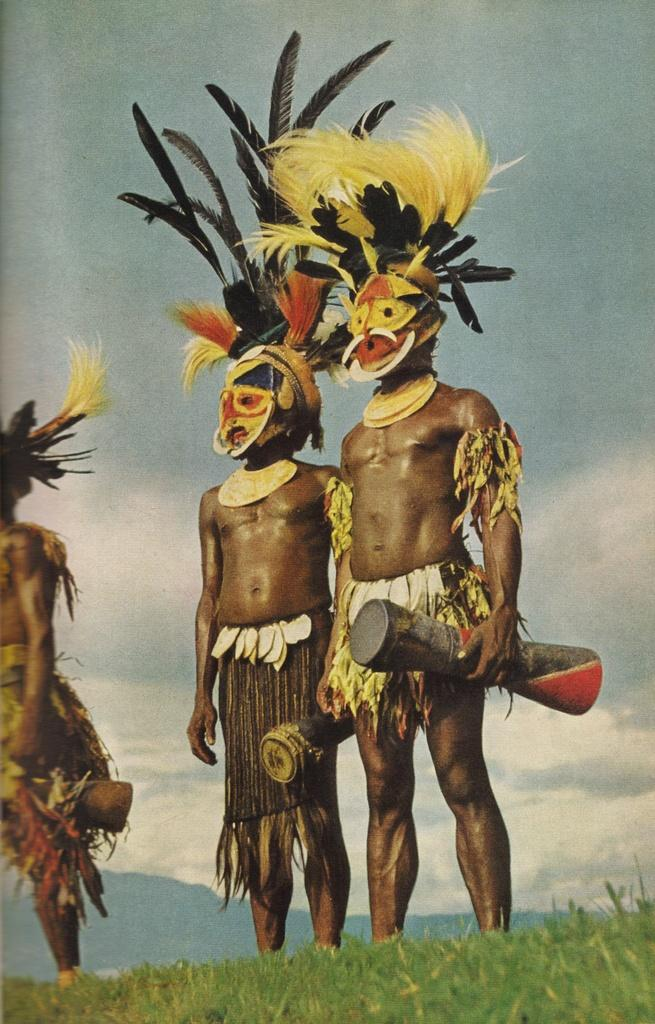How many people are in the image? There are three persons in the image. What are the persons doing in the image? The persons are standing and holding something. What is at the bottom of the image? There is grass at the bottom of the image. What can be seen in the background of the image? The sky is visible in the background of the image, and clouds are present. What type of waste can be seen in the image? There is no waste present in the image. What role does the minister play in the image? There is no minister present in the image. 